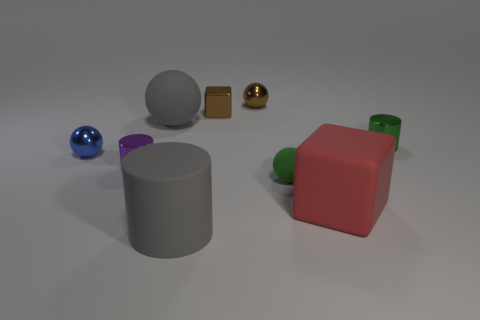How many other things are there of the same material as the large red object?
Give a very brief answer. 3. What material is the purple object that is the same size as the blue metal ball?
Your answer should be compact. Metal. There is a metal thing to the right of the tiny brown metallic sphere; is its shape the same as the green rubber object?
Give a very brief answer. No. Is the big ball the same color as the big cylinder?
Your response must be concise. Yes. How many things are small balls on the left side of the brown sphere or brown spheres?
Offer a terse response. 2. There is another green thing that is the same size as the green matte thing; what is its shape?
Keep it short and to the point. Cylinder. Does the rubber ball that is behind the tiny blue ball have the same size as the matte thing that is in front of the big cube?
Provide a succinct answer. Yes. There is a cube that is made of the same material as the brown ball; what is its color?
Your answer should be compact. Brown. Are the tiny sphere that is on the left side of the brown sphere and the green object that is in front of the blue metal thing made of the same material?
Ensure brevity in your answer.  No. Is there a blue shiny sphere that has the same size as the green cylinder?
Provide a succinct answer. Yes. 